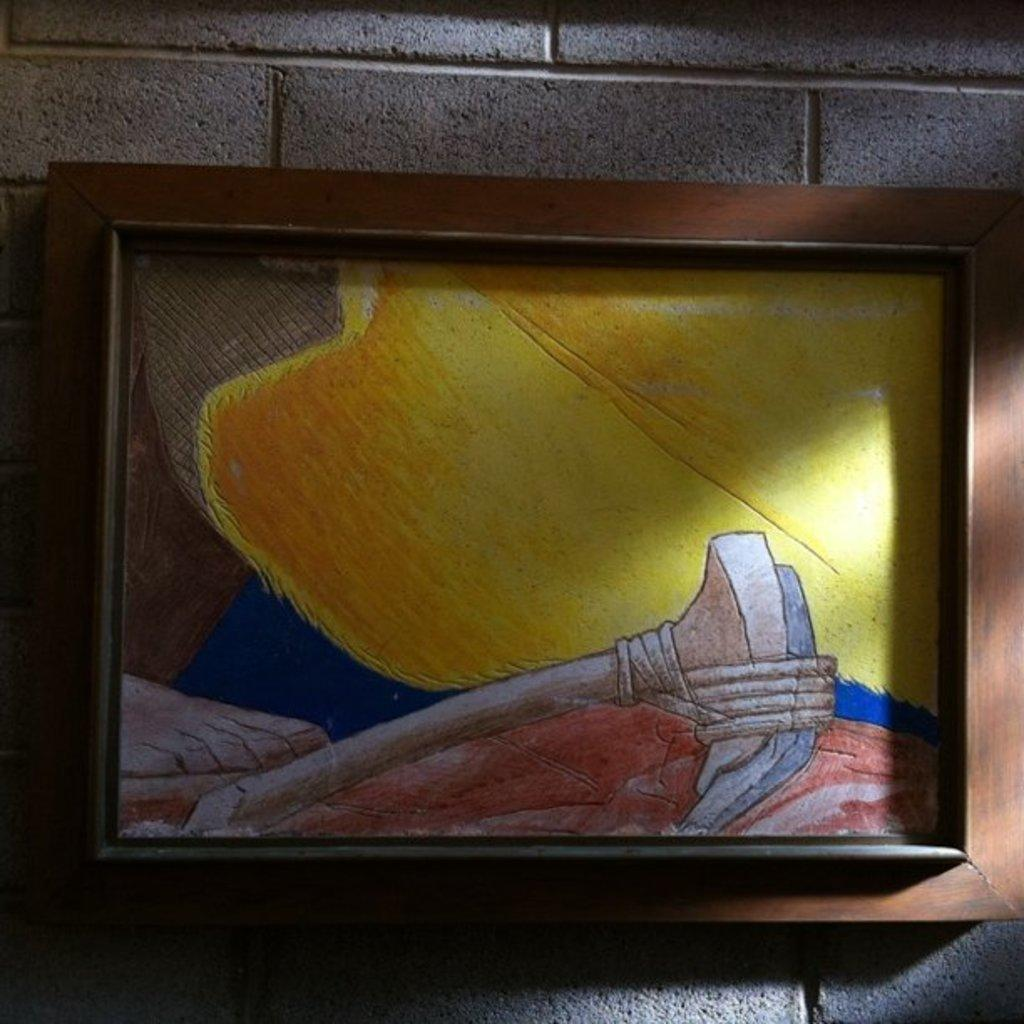What is displayed in the photo frame in the image? There is a colorful drawing in a photo frame. Where is the photo frame located in the image? The photo frame is hanging on a brick wall. What type of noise can be heard coming from the lock in the image? There is no lock present in the image, so it is not possible to determine what type of noise might be heard. 